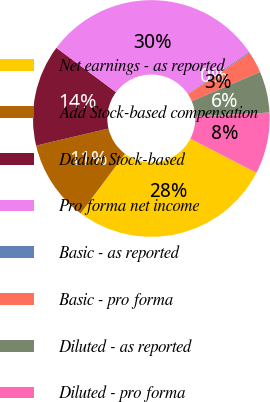<chart> <loc_0><loc_0><loc_500><loc_500><pie_chart><fcel>Net earnings - as reported<fcel>Add Stock-based compensation<fcel>Deduct Stock-based<fcel>Pro forma net income<fcel>Basic - as reported<fcel>Basic - pro forma<fcel>Diluted - as reported<fcel>Diluted - pro forma<nl><fcel>27.6%<fcel>11.13%<fcel>13.87%<fcel>30.34%<fcel>0.15%<fcel>2.89%<fcel>5.64%<fcel>8.38%<nl></chart> 